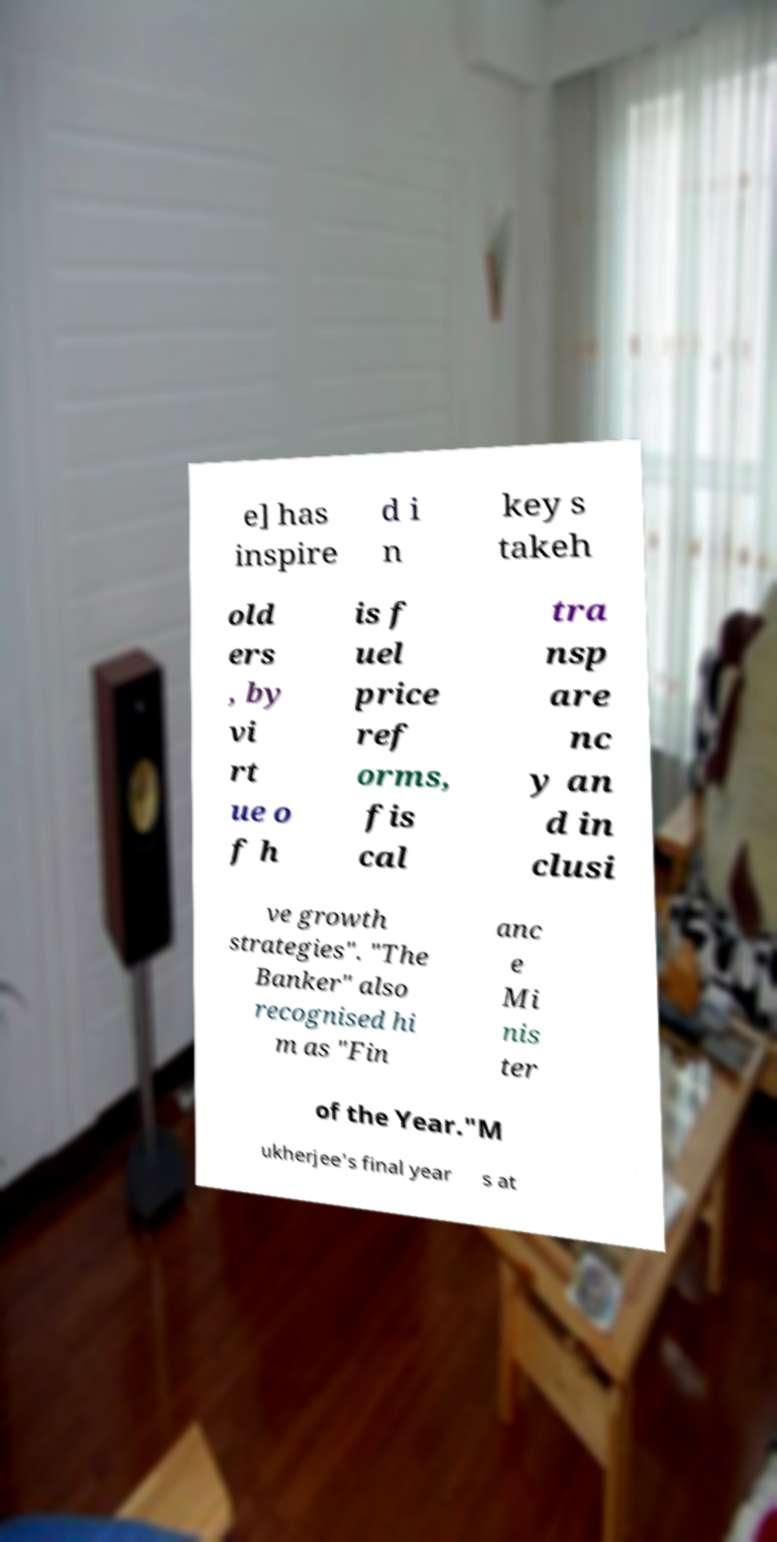There's text embedded in this image that I need extracted. Can you transcribe it verbatim? e] has inspire d i n key s takeh old ers , by vi rt ue o f h is f uel price ref orms, fis cal tra nsp are nc y an d in clusi ve growth strategies". "The Banker" also recognised hi m as "Fin anc e Mi nis ter of the Year."M ukherjee's final year s at 